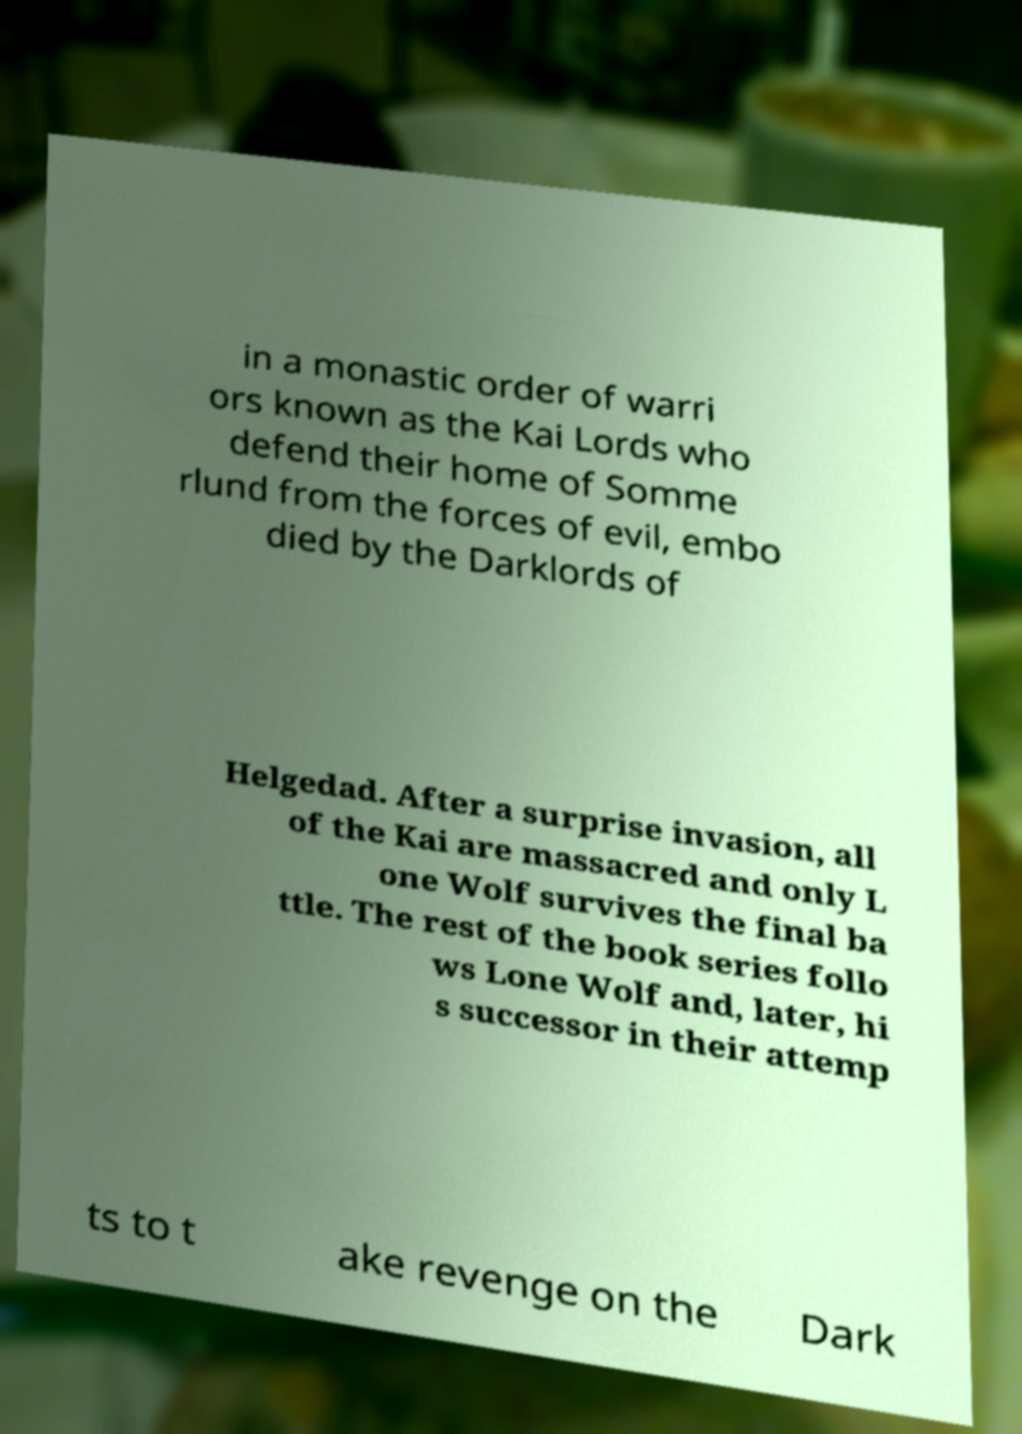There's text embedded in this image that I need extracted. Can you transcribe it verbatim? in a monastic order of warri ors known as the Kai Lords who defend their home of Somme rlund from the forces of evil, embo died by the Darklords of Helgedad. After a surprise invasion, all of the Kai are massacred and only L one Wolf survives the final ba ttle. The rest of the book series follo ws Lone Wolf and, later, hi s successor in their attemp ts to t ake revenge on the Dark 